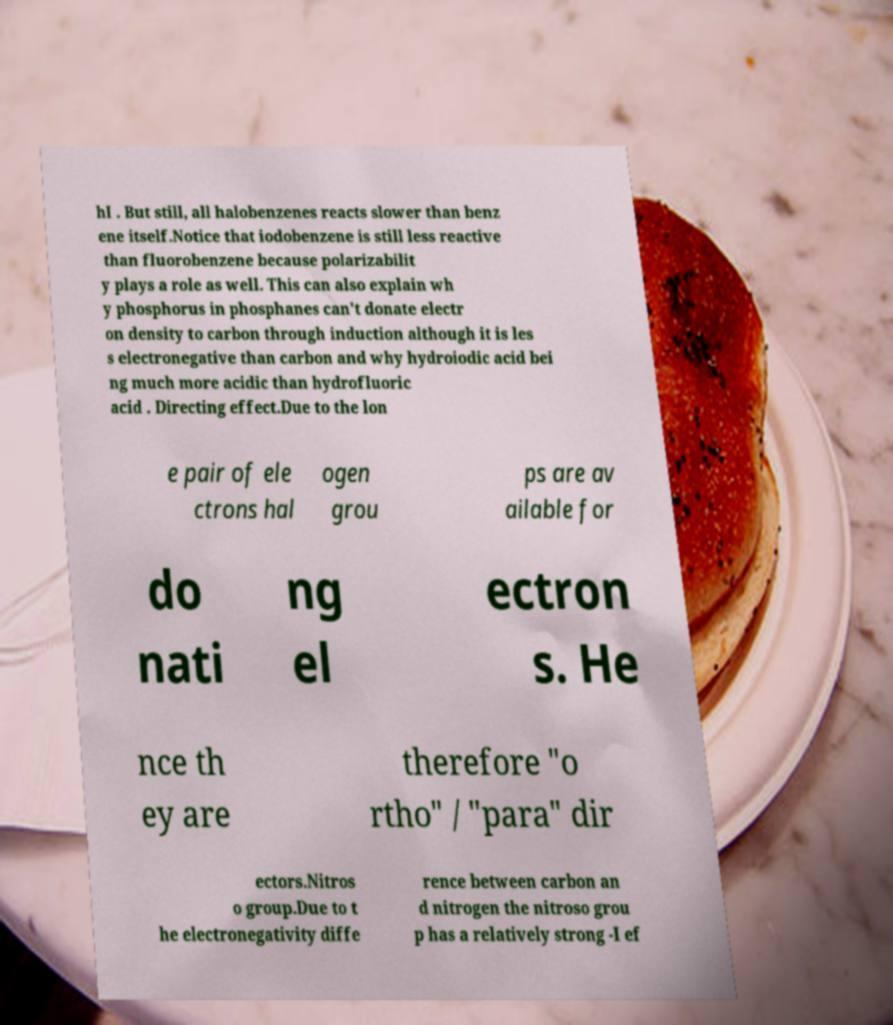Can you accurately transcribe the text from the provided image for me? hI . But still, all halobenzenes reacts slower than benz ene itself.Notice that iodobenzene is still less reactive than fluorobenzene because polarizabilit y plays a role as well. This can also explain wh y phosphorus in phosphanes can't donate electr on density to carbon through induction although it is les s electronegative than carbon and why hydroiodic acid bei ng much more acidic than hydrofluoric acid . Directing effect.Due to the lon e pair of ele ctrons hal ogen grou ps are av ailable for do nati ng el ectron s. He nce th ey are therefore "o rtho" / "para" dir ectors.Nitros o group.Due to t he electronegativity diffe rence between carbon an d nitrogen the nitroso grou p has a relatively strong -I ef 